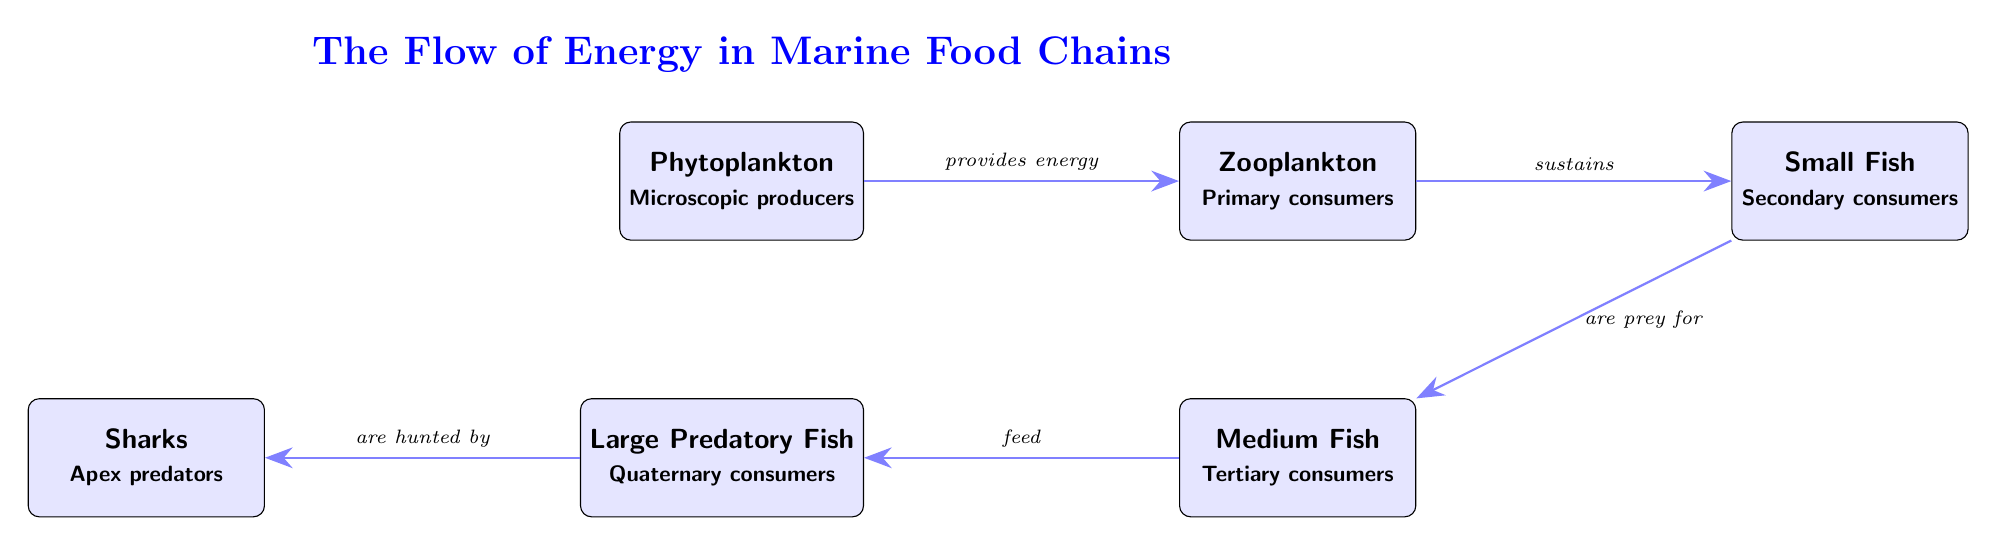What is the first node in the diagram? The first node in the diagram is labeled "Phytoplankton," which is identified as the starting point in the marine food chain.
Answer: Phytoplankton How many nodes are present in the diagram? The diagram contains a total of six nodes, each representing a different level in the marine food chain from producers to apex predators.
Answer: 6 Which node is considered the apex predator? The node labeled "Sharks" is indicated as the apex predator within the diagram, as it sits at the top of the food chain.
Answer: Sharks What type of consumers are Small Fish classified as? The diagram indicates that Small Fish are classified as "Secondary consumers," as they feed on primary consumers, which are Zooplankton.
Answer: Secondary consumers What flows from Phytoplankton to Zooplankton? The arrow from Phytoplankton to Zooplankton is labeled "provides energy," indicating that this is the flow of energy in the food chain.
Answer: provides energy How do Medium Fish interact with Large Predatory Fish? The diagram shows that Medium Fish are prey for Large Predatory Fish, as indicated by the directional arrow pointing from Medium Fish to Large Predatory Fish.
Answer: are prey for What is the relationship indicated between Large Predatory Fish and Sharks? The diagram states that Large Predatory Fish "are hunted by" Sharks, illustrating the predator-prey relationship between these two nodes.
Answer: are hunted by Which two nodes are connected by the sustenance relationship? The nodes connected by the sustenance relationship are Zooplankton and Small Fish, with the arrow specifying that Zooplankton sustains Small Fish.
Answer: Zooplankton and Small Fish Which node is directly below Zooplankton? In the diagram, the node directly beneath Zooplankton is labeled Medium Fish, indicating its position in the food web.
Answer: Medium Fish 